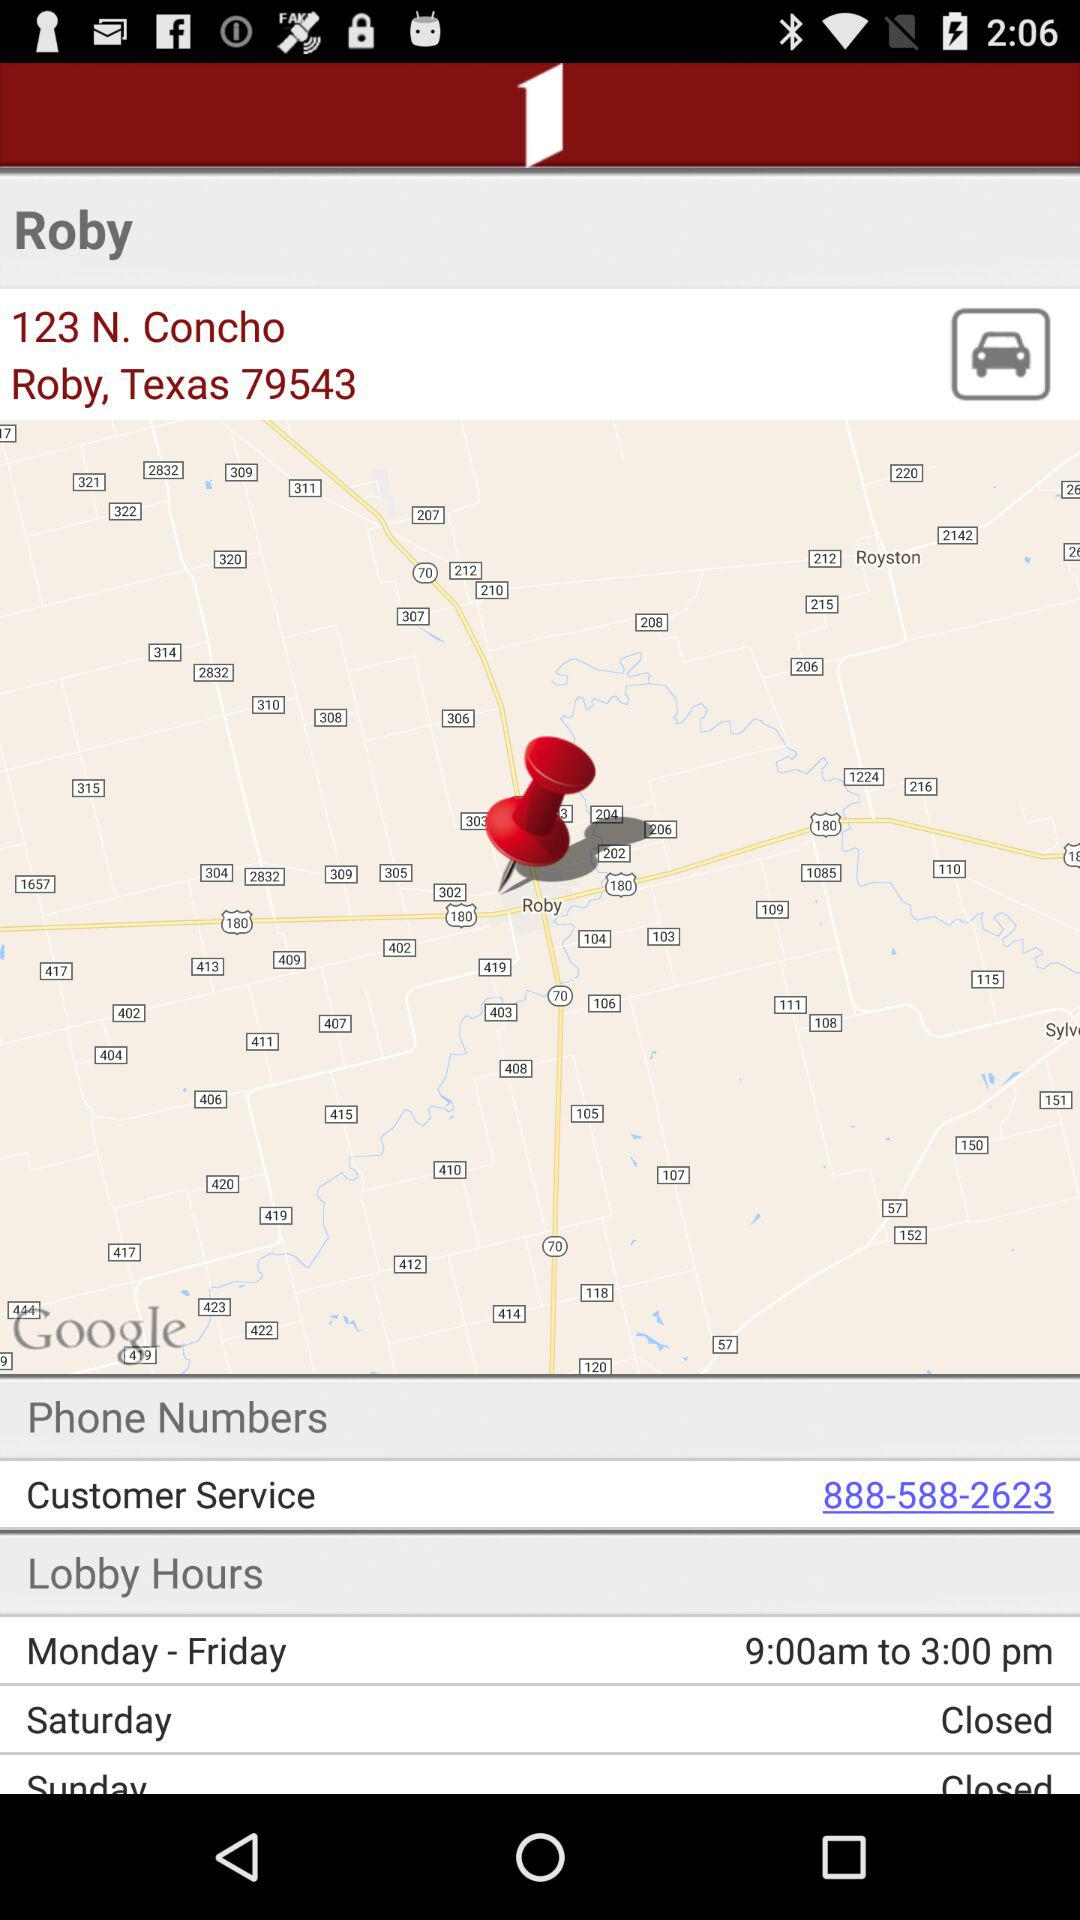Which place is it? The place is Roby. 